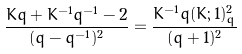Convert formula to latex. <formula><loc_0><loc_0><loc_500><loc_500>\frac { K q + K ^ { - 1 } q ^ { - 1 } - 2 } { ( q - q ^ { - 1 } ) ^ { 2 } } = \frac { K ^ { - 1 } q ( K ; 1 ) _ { q } ^ { 2 } } { ( q + 1 ) ^ { 2 } }</formula> 